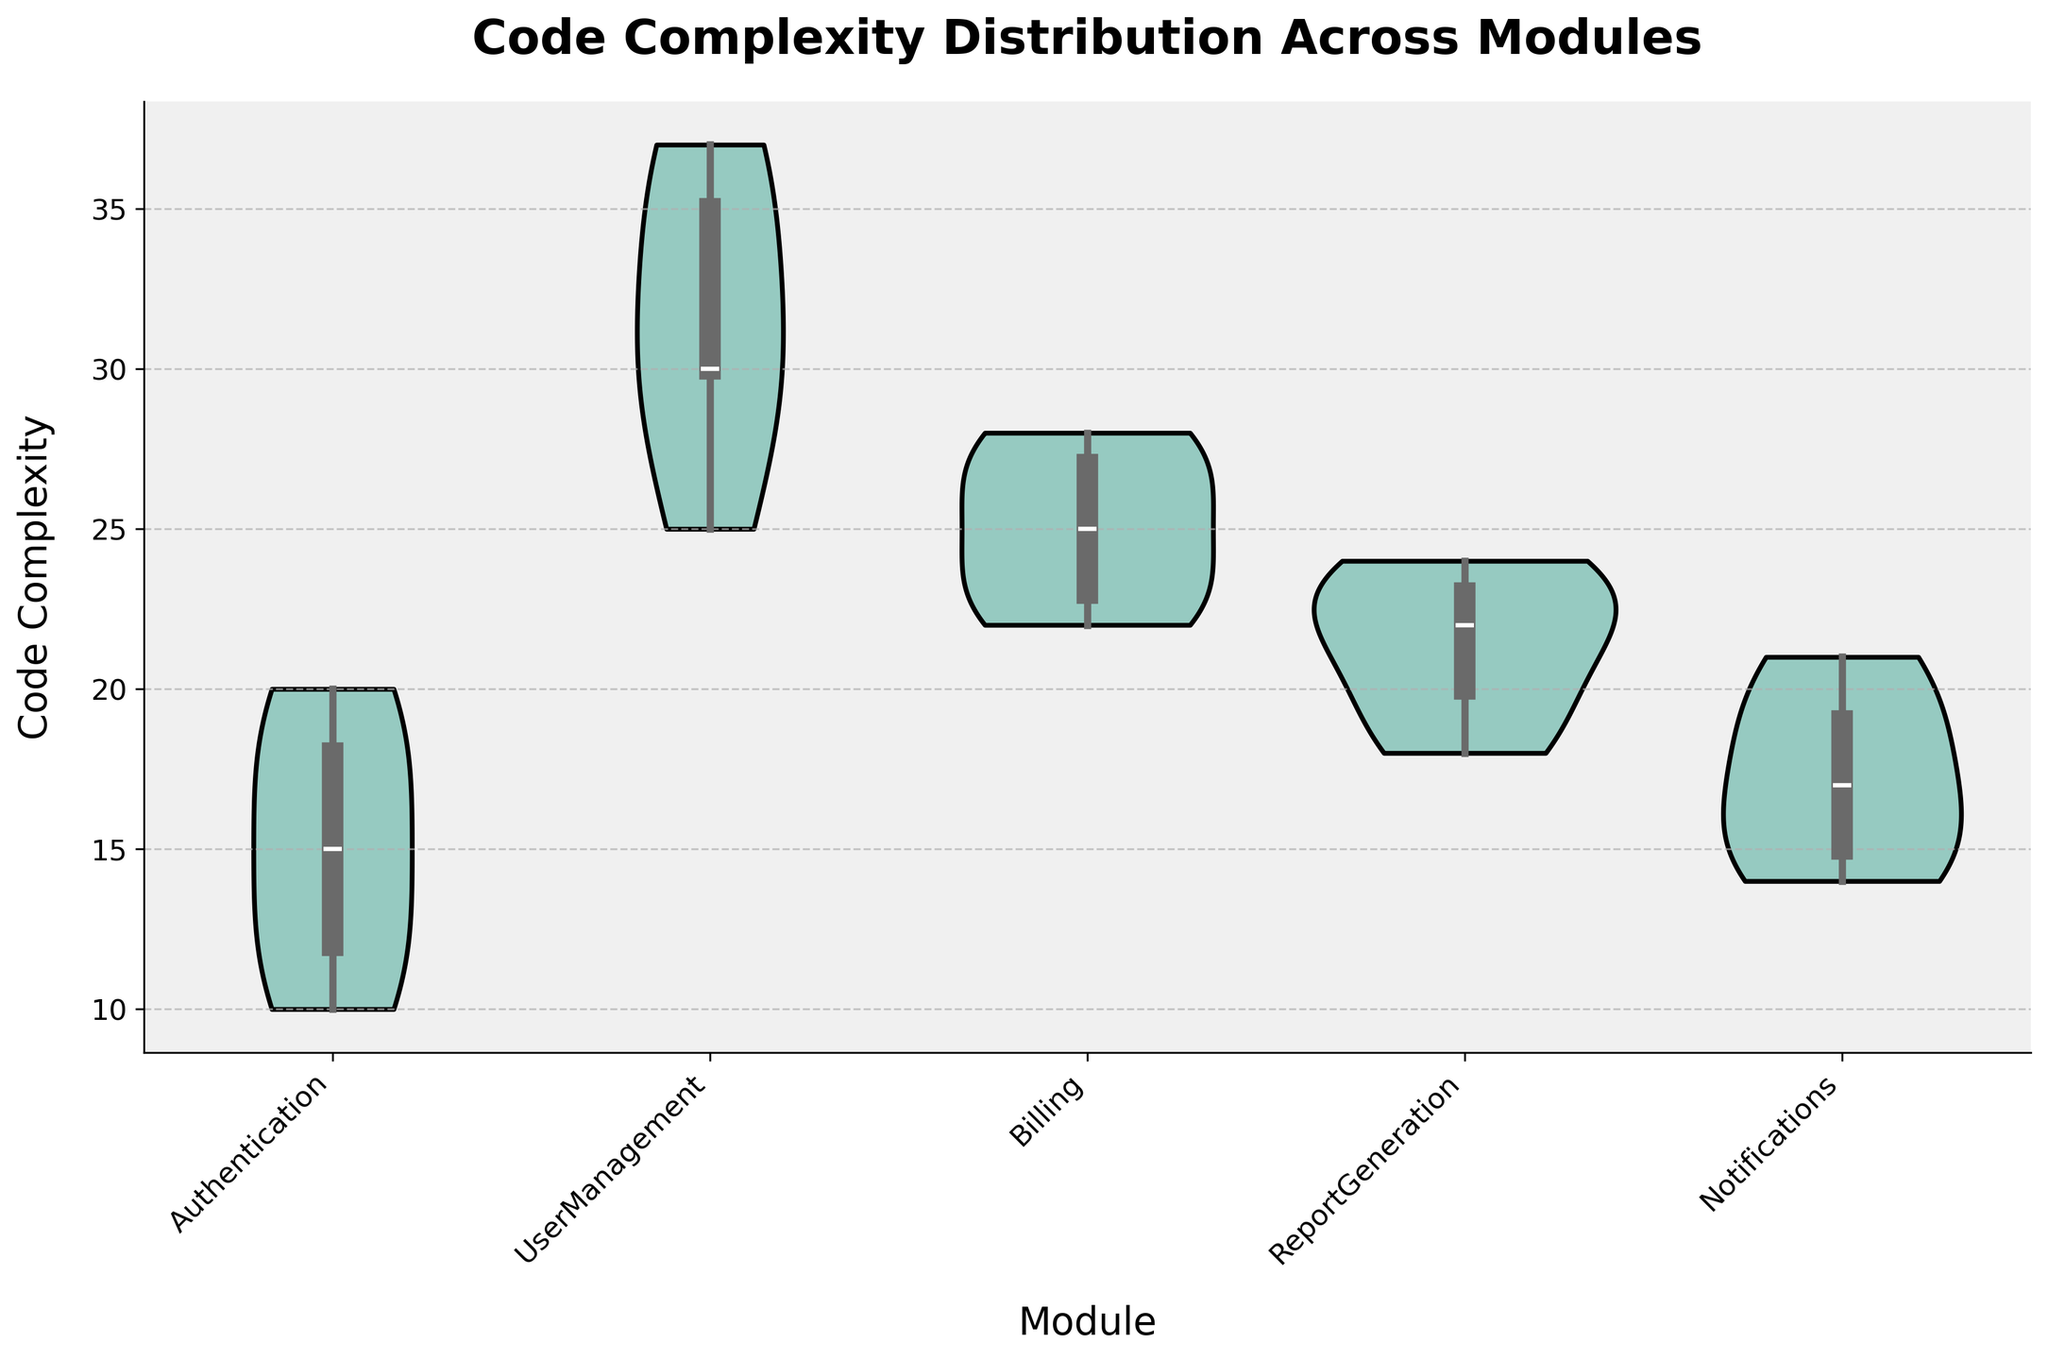What is the title of the plot? The title is usually located at the top center of the plot. Here, the text at the top reads "Code Complexity Distribution Across Modules".
Answer: Code Complexity Distribution Across Modules Which module appears to have the highest median code complexity? A violin plot's median is typically represented by the thickest part of the distribution. Here, UserManagement has the thickest part higher than other modules.
Answer: UserManagement What is the range of code complexity values in the Authentication module? The range can be determined by looking at the spread of the entire shaded area in the violin plot. For Authentication, the spread is from about 10 to 20.
Answer: 10 to 20 Which module has the widest distribution of code complexity values? The widest distribution will have the most spread in the violin plot, indicating a larger range between the maximum and minimum values. UserManagement shows the widest spread.
Answer: UserManagement How does the median code complexity of the Billing module compare to the ReportGeneration module? Comparing the thickest part (median) of the violin plot for Billing and ReportGeneration side by side, Billing's median (around 25) is higher than ReportGeneration's (around 21).
Answer: Billing's median is higher What does the shape of the Notification module's violin plot tell us about its code complexity distribution? The shape of a violin plot indicates the density of values. Notifications has a relatively symmetrical and uniform shape, suggesting consistent code complexity values around the median.
Answer: Consistent around the median How many modules are compared in this plot? The x-axis labels each module. Counting these labels gives us the number of modules being compared. There are six modules: Authentication, UserManagement, Billing, ReportGeneration, Notifications.
Answer: 5 Which module has the lowest code complexity values? The lowest values in the violin plot are indicated by the bottom of the shaded area. Authentication has the lowest values starting around 10.
Answer: Authentication Does the ReportGeneration module have any outliers in its code complexity values? Outliers would be shown as individual points outside the main distribution. The ReportGeneration module does not display any such points, indicating no outliers.
Answer: No How do the spreads of complexity values for Billing and Notifications compare? The spread can be compared by observing the thickness and extent of the shaded area. Billing has a wider spread from about 22 to 28, whereas Notifications ranges from 14 to 21.
Answer: Billing's spread is wider 